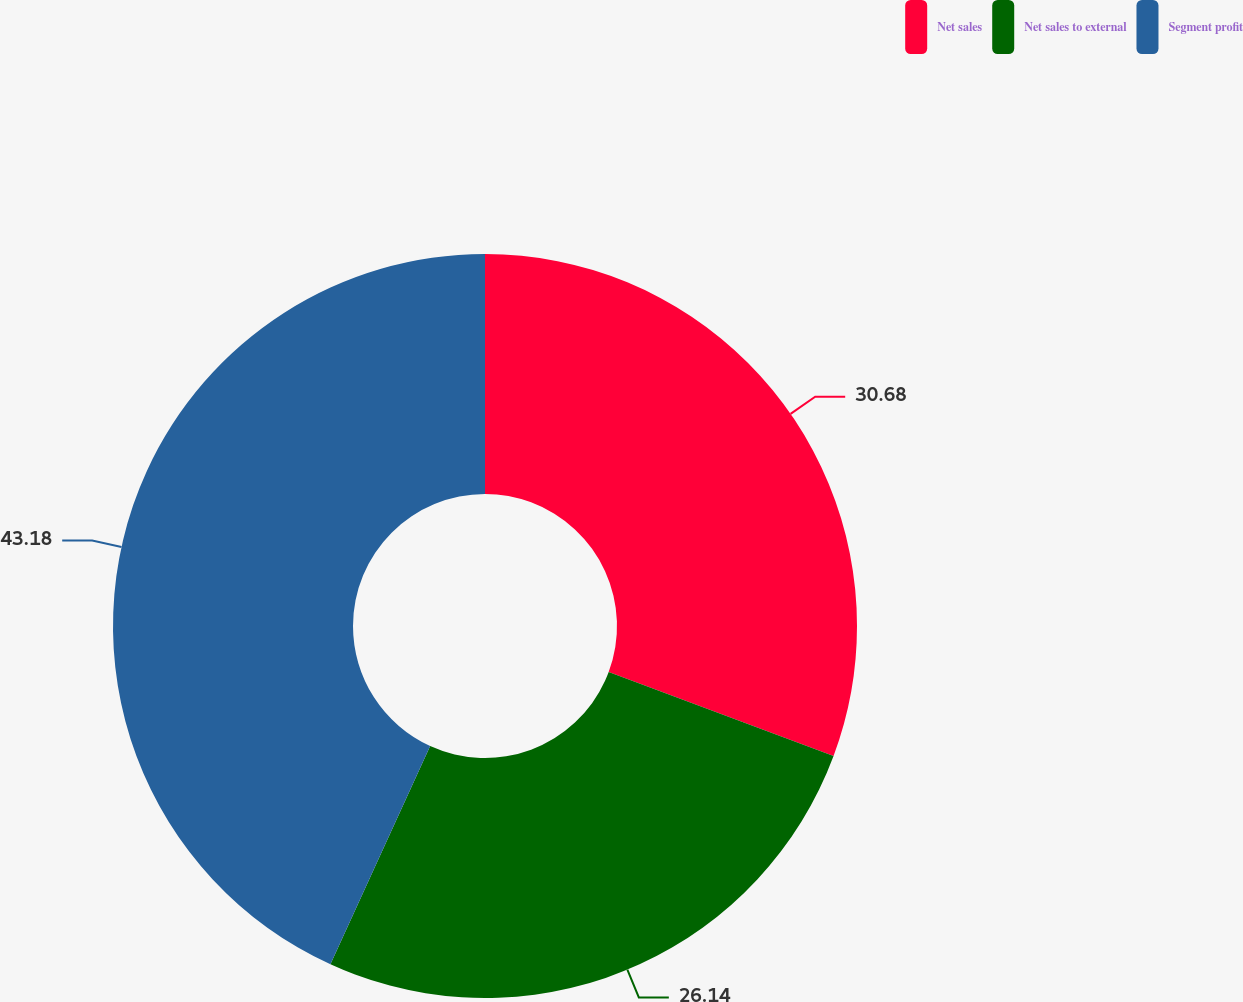Convert chart. <chart><loc_0><loc_0><loc_500><loc_500><pie_chart><fcel>Net sales<fcel>Net sales to external<fcel>Segment profit<nl><fcel>30.68%<fcel>26.14%<fcel>43.18%<nl></chart> 